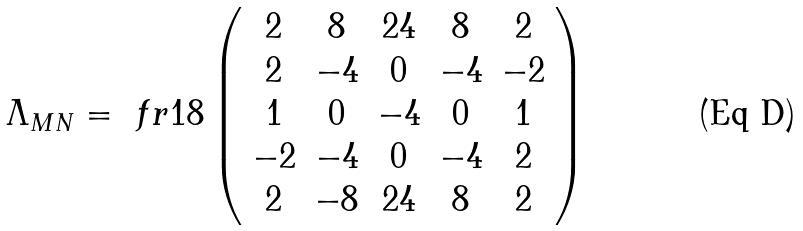<formula> <loc_0><loc_0><loc_500><loc_500>\Lambda _ { M N } = \ f r { 1 } { 8 } \left ( \begin{array} { c c c c c } 2 & 8 & 2 4 & 8 & 2 \\ 2 & - 4 & 0 & - 4 & - 2 \\ 1 & 0 & - 4 & 0 & 1 \\ - 2 & - 4 & 0 & - 4 & 2 \\ 2 & - 8 & 2 4 & 8 & 2 \end{array} \right )</formula> 